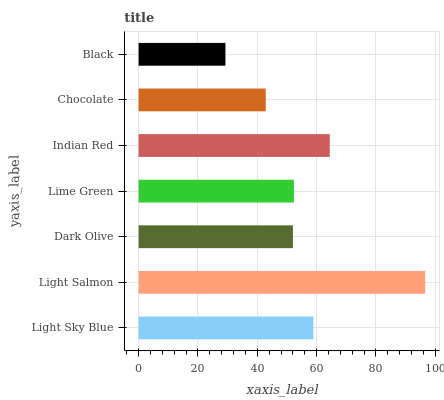Is Black the minimum?
Answer yes or no. Yes. Is Light Salmon the maximum?
Answer yes or no. Yes. Is Dark Olive the minimum?
Answer yes or no. No. Is Dark Olive the maximum?
Answer yes or no. No. Is Light Salmon greater than Dark Olive?
Answer yes or no. Yes. Is Dark Olive less than Light Salmon?
Answer yes or no. Yes. Is Dark Olive greater than Light Salmon?
Answer yes or no. No. Is Light Salmon less than Dark Olive?
Answer yes or no. No. Is Lime Green the high median?
Answer yes or no. Yes. Is Lime Green the low median?
Answer yes or no. Yes. Is Light Sky Blue the high median?
Answer yes or no. No. Is Chocolate the low median?
Answer yes or no. No. 